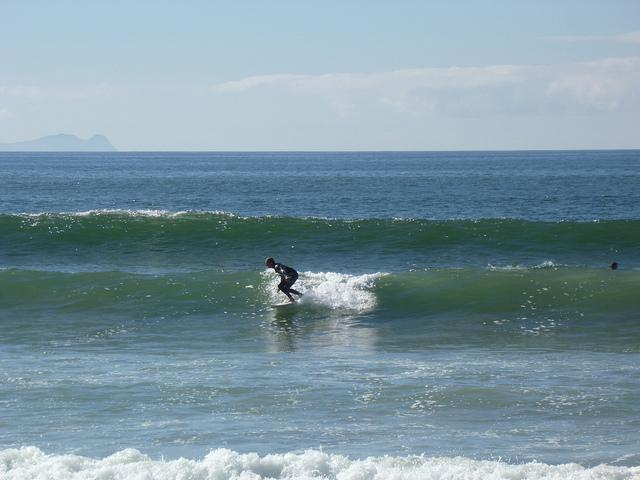What is a term related to this event? surfing 